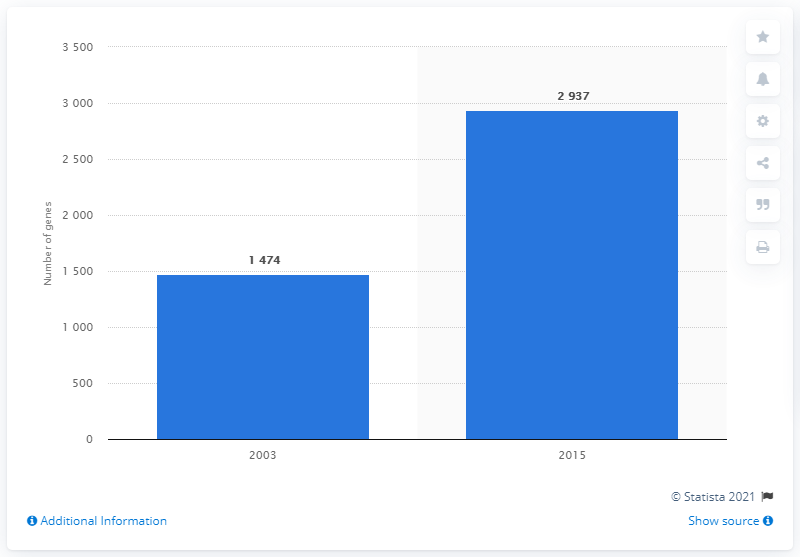List a handful of essential elements in this visual. The Human Genome Project was completed in 2003. 